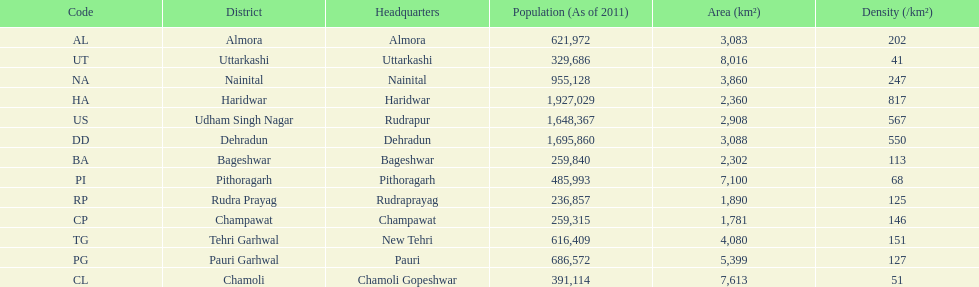Tell me a district that only has a density of 51. Chamoli. 